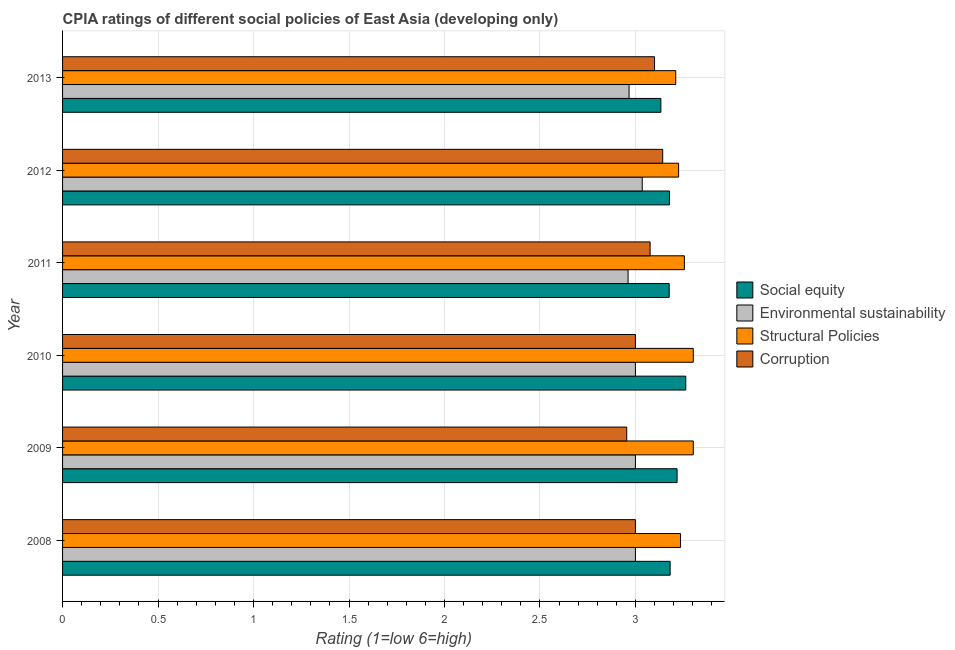How many bars are there on the 3rd tick from the top?
Provide a short and direct response. 4. How many bars are there on the 6th tick from the bottom?
Your response must be concise. 4. What is the label of the 6th group of bars from the top?
Provide a succinct answer. 2008. What is the cpia rating of structural policies in 2011?
Offer a terse response. 3.26. Across all years, what is the maximum cpia rating of corruption?
Your answer should be compact. 3.14. Across all years, what is the minimum cpia rating of social equity?
Your answer should be compact. 3.13. In which year was the cpia rating of structural policies maximum?
Your answer should be very brief. 2009. What is the total cpia rating of structural policies in the graph?
Provide a succinct answer. 19.54. What is the difference between the cpia rating of corruption in 2010 and that in 2011?
Your answer should be very brief. -0.08. What is the difference between the cpia rating of social equity in 2008 and the cpia rating of structural policies in 2012?
Your response must be concise. -0.04. What is the average cpia rating of social equity per year?
Make the answer very short. 3.19. In the year 2008, what is the difference between the cpia rating of corruption and cpia rating of social equity?
Offer a very short reply. -0.18. In how many years, is the cpia rating of structural policies greater than 2.3 ?
Your answer should be very brief. 6. What is the ratio of the cpia rating of structural policies in 2009 to that in 2012?
Give a very brief answer. 1.02. What is the difference between the highest and the lowest cpia rating of structural policies?
Ensure brevity in your answer.  0.09. Is the sum of the cpia rating of social equity in 2011 and 2013 greater than the maximum cpia rating of structural policies across all years?
Your answer should be very brief. Yes. What does the 4th bar from the top in 2009 represents?
Your response must be concise. Social equity. What does the 2nd bar from the bottom in 2009 represents?
Provide a succinct answer. Environmental sustainability. How many bars are there?
Your answer should be compact. 24. What is the difference between two consecutive major ticks on the X-axis?
Offer a terse response. 0.5. Are the values on the major ticks of X-axis written in scientific E-notation?
Provide a succinct answer. No. Does the graph contain any zero values?
Offer a terse response. No. Does the graph contain grids?
Offer a terse response. Yes. How many legend labels are there?
Give a very brief answer. 4. How are the legend labels stacked?
Provide a succinct answer. Vertical. What is the title of the graph?
Make the answer very short. CPIA ratings of different social policies of East Asia (developing only). Does "Tertiary schools" appear as one of the legend labels in the graph?
Offer a terse response. No. What is the label or title of the Y-axis?
Offer a terse response. Year. What is the Rating (1=low 6=high) of Social equity in 2008?
Provide a succinct answer. 3.18. What is the Rating (1=low 6=high) of Environmental sustainability in 2008?
Your answer should be compact. 3. What is the Rating (1=low 6=high) in Structural Policies in 2008?
Offer a very short reply. 3.24. What is the Rating (1=low 6=high) in Social equity in 2009?
Offer a very short reply. 3.22. What is the Rating (1=low 6=high) of Environmental sustainability in 2009?
Keep it short and to the point. 3. What is the Rating (1=low 6=high) in Structural Policies in 2009?
Ensure brevity in your answer.  3.3. What is the Rating (1=low 6=high) of Corruption in 2009?
Offer a terse response. 2.95. What is the Rating (1=low 6=high) of Social equity in 2010?
Your answer should be very brief. 3.26. What is the Rating (1=low 6=high) of Environmental sustainability in 2010?
Offer a very short reply. 3. What is the Rating (1=low 6=high) of Structural Policies in 2010?
Offer a very short reply. 3.3. What is the Rating (1=low 6=high) of Social equity in 2011?
Make the answer very short. 3.18. What is the Rating (1=low 6=high) of Environmental sustainability in 2011?
Your answer should be compact. 2.96. What is the Rating (1=low 6=high) in Structural Policies in 2011?
Provide a short and direct response. 3.26. What is the Rating (1=low 6=high) of Corruption in 2011?
Your answer should be compact. 3.08. What is the Rating (1=low 6=high) of Social equity in 2012?
Ensure brevity in your answer.  3.18. What is the Rating (1=low 6=high) of Environmental sustainability in 2012?
Make the answer very short. 3.04. What is the Rating (1=low 6=high) in Structural Policies in 2012?
Offer a very short reply. 3.23. What is the Rating (1=low 6=high) of Corruption in 2012?
Your answer should be very brief. 3.14. What is the Rating (1=low 6=high) in Social equity in 2013?
Your answer should be very brief. 3.13. What is the Rating (1=low 6=high) of Environmental sustainability in 2013?
Offer a very short reply. 2.97. What is the Rating (1=low 6=high) in Structural Policies in 2013?
Keep it short and to the point. 3.21. What is the Rating (1=low 6=high) in Corruption in 2013?
Your answer should be very brief. 3.1. Across all years, what is the maximum Rating (1=low 6=high) in Social equity?
Ensure brevity in your answer.  3.26. Across all years, what is the maximum Rating (1=low 6=high) in Environmental sustainability?
Give a very brief answer. 3.04. Across all years, what is the maximum Rating (1=low 6=high) in Structural Policies?
Make the answer very short. 3.3. Across all years, what is the maximum Rating (1=low 6=high) of Corruption?
Provide a succinct answer. 3.14. Across all years, what is the minimum Rating (1=low 6=high) of Social equity?
Provide a succinct answer. 3.13. Across all years, what is the minimum Rating (1=low 6=high) of Environmental sustainability?
Your answer should be compact. 2.96. Across all years, what is the minimum Rating (1=low 6=high) of Structural Policies?
Ensure brevity in your answer.  3.21. Across all years, what is the minimum Rating (1=low 6=high) of Corruption?
Provide a short and direct response. 2.95. What is the total Rating (1=low 6=high) in Social equity in the graph?
Keep it short and to the point. 19.15. What is the total Rating (1=low 6=high) in Environmental sustainability in the graph?
Make the answer very short. 17.96. What is the total Rating (1=low 6=high) in Structural Policies in the graph?
Offer a terse response. 19.54. What is the total Rating (1=low 6=high) of Corruption in the graph?
Your response must be concise. 18.27. What is the difference between the Rating (1=low 6=high) in Social equity in 2008 and that in 2009?
Keep it short and to the point. -0.04. What is the difference between the Rating (1=low 6=high) of Environmental sustainability in 2008 and that in 2009?
Your answer should be compact. 0. What is the difference between the Rating (1=low 6=high) in Structural Policies in 2008 and that in 2009?
Offer a very short reply. -0.07. What is the difference between the Rating (1=low 6=high) of Corruption in 2008 and that in 2009?
Your answer should be compact. 0.05. What is the difference between the Rating (1=low 6=high) of Social equity in 2008 and that in 2010?
Offer a terse response. -0.08. What is the difference between the Rating (1=low 6=high) of Structural Policies in 2008 and that in 2010?
Offer a terse response. -0.07. What is the difference between the Rating (1=low 6=high) of Social equity in 2008 and that in 2011?
Ensure brevity in your answer.  0. What is the difference between the Rating (1=low 6=high) of Environmental sustainability in 2008 and that in 2011?
Make the answer very short. 0.04. What is the difference between the Rating (1=low 6=high) in Structural Policies in 2008 and that in 2011?
Provide a succinct answer. -0.02. What is the difference between the Rating (1=low 6=high) in Corruption in 2008 and that in 2011?
Provide a succinct answer. -0.08. What is the difference between the Rating (1=low 6=high) of Social equity in 2008 and that in 2012?
Offer a terse response. 0. What is the difference between the Rating (1=low 6=high) in Environmental sustainability in 2008 and that in 2012?
Your answer should be very brief. -0.04. What is the difference between the Rating (1=low 6=high) in Structural Policies in 2008 and that in 2012?
Offer a very short reply. 0.01. What is the difference between the Rating (1=low 6=high) in Corruption in 2008 and that in 2012?
Offer a terse response. -0.14. What is the difference between the Rating (1=low 6=high) in Social equity in 2008 and that in 2013?
Make the answer very short. 0.05. What is the difference between the Rating (1=low 6=high) of Structural Policies in 2008 and that in 2013?
Ensure brevity in your answer.  0.03. What is the difference between the Rating (1=low 6=high) in Corruption in 2008 and that in 2013?
Provide a succinct answer. -0.1. What is the difference between the Rating (1=low 6=high) in Social equity in 2009 and that in 2010?
Provide a short and direct response. -0.05. What is the difference between the Rating (1=low 6=high) in Environmental sustainability in 2009 and that in 2010?
Make the answer very short. 0. What is the difference between the Rating (1=low 6=high) in Corruption in 2009 and that in 2010?
Provide a succinct answer. -0.05. What is the difference between the Rating (1=low 6=high) of Social equity in 2009 and that in 2011?
Offer a terse response. 0.04. What is the difference between the Rating (1=low 6=high) of Environmental sustainability in 2009 and that in 2011?
Your answer should be compact. 0.04. What is the difference between the Rating (1=low 6=high) of Structural Policies in 2009 and that in 2011?
Offer a very short reply. 0.05. What is the difference between the Rating (1=low 6=high) in Corruption in 2009 and that in 2011?
Make the answer very short. -0.12. What is the difference between the Rating (1=low 6=high) in Social equity in 2009 and that in 2012?
Make the answer very short. 0.04. What is the difference between the Rating (1=low 6=high) of Environmental sustainability in 2009 and that in 2012?
Provide a short and direct response. -0.04. What is the difference between the Rating (1=low 6=high) of Structural Policies in 2009 and that in 2012?
Provide a short and direct response. 0.08. What is the difference between the Rating (1=low 6=high) in Corruption in 2009 and that in 2012?
Provide a short and direct response. -0.19. What is the difference between the Rating (1=low 6=high) of Social equity in 2009 and that in 2013?
Your response must be concise. 0.08. What is the difference between the Rating (1=low 6=high) of Environmental sustainability in 2009 and that in 2013?
Make the answer very short. 0.03. What is the difference between the Rating (1=low 6=high) in Structural Policies in 2009 and that in 2013?
Your answer should be compact. 0.09. What is the difference between the Rating (1=low 6=high) in Corruption in 2009 and that in 2013?
Your answer should be very brief. -0.15. What is the difference between the Rating (1=low 6=high) in Social equity in 2010 and that in 2011?
Offer a terse response. 0.09. What is the difference between the Rating (1=low 6=high) in Environmental sustainability in 2010 and that in 2011?
Offer a terse response. 0.04. What is the difference between the Rating (1=low 6=high) in Structural Policies in 2010 and that in 2011?
Your response must be concise. 0.05. What is the difference between the Rating (1=low 6=high) of Corruption in 2010 and that in 2011?
Your answer should be very brief. -0.08. What is the difference between the Rating (1=low 6=high) of Social equity in 2010 and that in 2012?
Keep it short and to the point. 0.09. What is the difference between the Rating (1=low 6=high) in Environmental sustainability in 2010 and that in 2012?
Offer a very short reply. -0.04. What is the difference between the Rating (1=low 6=high) of Structural Policies in 2010 and that in 2012?
Offer a terse response. 0.08. What is the difference between the Rating (1=low 6=high) of Corruption in 2010 and that in 2012?
Give a very brief answer. -0.14. What is the difference between the Rating (1=low 6=high) of Social equity in 2010 and that in 2013?
Keep it short and to the point. 0.13. What is the difference between the Rating (1=low 6=high) of Environmental sustainability in 2010 and that in 2013?
Keep it short and to the point. 0.03. What is the difference between the Rating (1=low 6=high) of Structural Policies in 2010 and that in 2013?
Keep it short and to the point. 0.09. What is the difference between the Rating (1=low 6=high) of Corruption in 2010 and that in 2013?
Your answer should be very brief. -0.1. What is the difference between the Rating (1=low 6=high) in Social equity in 2011 and that in 2012?
Offer a terse response. -0. What is the difference between the Rating (1=low 6=high) of Environmental sustainability in 2011 and that in 2012?
Make the answer very short. -0.07. What is the difference between the Rating (1=low 6=high) of Structural Policies in 2011 and that in 2012?
Offer a very short reply. 0.03. What is the difference between the Rating (1=low 6=high) in Corruption in 2011 and that in 2012?
Offer a very short reply. -0.07. What is the difference between the Rating (1=low 6=high) of Social equity in 2011 and that in 2013?
Your answer should be very brief. 0.04. What is the difference between the Rating (1=low 6=high) of Environmental sustainability in 2011 and that in 2013?
Your answer should be very brief. -0.01. What is the difference between the Rating (1=low 6=high) in Structural Policies in 2011 and that in 2013?
Offer a terse response. 0.05. What is the difference between the Rating (1=low 6=high) in Corruption in 2011 and that in 2013?
Ensure brevity in your answer.  -0.02. What is the difference between the Rating (1=low 6=high) of Social equity in 2012 and that in 2013?
Give a very brief answer. 0.05. What is the difference between the Rating (1=low 6=high) in Environmental sustainability in 2012 and that in 2013?
Your answer should be very brief. 0.07. What is the difference between the Rating (1=low 6=high) in Structural Policies in 2012 and that in 2013?
Provide a succinct answer. 0.02. What is the difference between the Rating (1=low 6=high) of Corruption in 2012 and that in 2013?
Your answer should be compact. 0.04. What is the difference between the Rating (1=low 6=high) of Social equity in 2008 and the Rating (1=low 6=high) of Environmental sustainability in 2009?
Offer a very short reply. 0.18. What is the difference between the Rating (1=low 6=high) of Social equity in 2008 and the Rating (1=low 6=high) of Structural Policies in 2009?
Make the answer very short. -0.12. What is the difference between the Rating (1=low 6=high) of Social equity in 2008 and the Rating (1=low 6=high) of Corruption in 2009?
Your answer should be compact. 0.23. What is the difference between the Rating (1=low 6=high) of Environmental sustainability in 2008 and the Rating (1=low 6=high) of Structural Policies in 2009?
Offer a very short reply. -0.3. What is the difference between the Rating (1=low 6=high) in Environmental sustainability in 2008 and the Rating (1=low 6=high) in Corruption in 2009?
Keep it short and to the point. 0.05. What is the difference between the Rating (1=low 6=high) of Structural Policies in 2008 and the Rating (1=low 6=high) of Corruption in 2009?
Your response must be concise. 0.28. What is the difference between the Rating (1=low 6=high) in Social equity in 2008 and the Rating (1=low 6=high) in Environmental sustainability in 2010?
Ensure brevity in your answer.  0.18. What is the difference between the Rating (1=low 6=high) in Social equity in 2008 and the Rating (1=low 6=high) in Structural Policies in 2010?
Provide a succinct answer. -0.12. What is the difference between the Rating (1=low 6=high) of Social equity in 2008 and the Rating (1=low 6=high) of Corruption in 2010?
Give a very brief answer. 0.18. What is the difference between the Rating (1=low 6=high) in Environmental sustainability in 2008 and the Rating (1=low 6=high) in Structural Policies in 2010?
Your answer should be compact. -0.3. What is the difference between the Rating (1=low 6=high) in Environmental sustainability in 2008 and the Rating (1=low 6=high) in Corruption in 2010?
Ensure brevity in your answer.  0. What is the difference between the Rating (1=low 6=high) of Structural Policies in 2008 and the Rating (1=low 6=high) of Corruption in 2010?
Offer a very short reply. 0.24. What is the difference between the Rating (1=low 6=high) of Social equity in 2008 and the Rating (1=low 6=high) of Environmental sustainability in 2011?
Keep it short and to the point. 0.22. What is the difference between the Rating (1=low 6=high) in Social equity in 2008 and the Rating (1=low 6=high) in Structural Policies in 2011?
Your answer should be very brief. -0.07. What is the difference between the Rating (1=low 6=high) in Social equity in 2008 and the Rating (1=low 6=high) in Corruption in 2011?
Offer a terse response. 0.1. What is the difference between the Rating (1=low 6=high) of Environmental sustainability in 2008 and the Rating (1=low 6=high) of Structural Policies in 2011?
Your answer should be compact. -0.26. What is the difference between the Rating (1=low 6=high) of Environmental sustainability in 2008 and the Rating (1=low 6=high) of Corruption in 2011?
Make the answer very short. -0.08. What is the difference between the Rating (1=low 6=high) of Structural Policies in 2008 and the Rating (1=low 6=high) of Corruption in 2011?
Offer a very short reply. 0.16. What is the difference between the Rating (1=low 6=high) in Social equity in 2008 and the Rating (1=low 6=high) in Environmental sustainability in 2012?
Provide a short and direct response. 0.15. What is the difference between the Rating (1=low 6=high) in Social equity in 2008 and the Rating (1=low 6=high) in Structural Policies in 2012?
Provide a succinct answer. -0.04. What is the difference between the Rating (1=low 6=high) in Social equity in 2008 and the Rating (1=low 6=high) in Corruption in 2012?
Keep it short and to the point. 0.04. What is the difference between the Rating (1=low 6=high) of Environmental sustainability in 2008 and the Rating (1=low 6=high) of Structural Policies in 2012?
Your answer should be very brief. -0.23. What is the difference between the Rating (1=low 6=high) in Environmental sustainability in 2008 and the Rating (1=low 6=high) in Corruption in 2012?
Give a very brief answer. -0.14. What is the difference between the Rating (1=low 6=high) in Structural Policies in 2008 and the Rating (1=low 6=high) in Corruption in 2012?
Ensure brevity in your answer.  0.09. What is the difference between the Rating (1=low 6=high) of Social equity in 2008 and the Rating (1=low 6=high) of Environmental sustainability in 2013?
Give a very brief answer. 0.22. What is the difference between the Rating (1=low 6=high) in Social equity in 2008 and the Rating (1=low 6=high) in Structural Policies in 2013?
Make the answer very short. -0.03. What is the difference between the Rating (1=low 6=high) of Social equity in 2008 and the Rating (1=low 6=high) of Corruption in 2013?
Offer a very short reply. 0.08. What is the difference between the Rating (1=low 6=high) of Environmental sustainability in 2008 and the Rating (1=low 6=high) of Structural Policies in 2013?
Provide a succinct answer. -0.21. What is the difference between the Rating (1=low 6=high) of Structural Policies in 2008 and the Rating (1=low 6=high) of Corruption in 2013?
Your answer should be compact. 0.14. What is the difference between the Rating (1=low 6=high) in Social equity in 2009 and the Rating (1=low 6=high) in Environmental sustainability in 2010?
Offer a terse response. 0.22. What is the difference between the Rating (1=low 6=high) in Social equity in 2009 and the Rating (1=low 6=high) in Structural Policies in 2010?
Give a very brief answer. -0.08. What is the difference between the Rating (1=low 6=high) of Social equity in 2009 and the Rating (1=low 6=high) of Corruption in 2010?
Your answer should be very brief. 0.22. What is the difference between the Rating (1=low 6=high) in Environmental sustainability in 2009 and the Rating (1=low 6=high) in Structural Policies in 2010?
Provide a succinct answer. -0.3. What is the difference between the Rating (1=low 6=high) in Environmental sustainability in 2009 and the Rating (1=low 6=high) in Corruption in 2010?
Provide a succinct answer. 0. What is the difference between the Rating (1=low 6=high) of Structural Policies in 2009 and the Rating (1=low 6=high) of Corruption in 2010?
Provide a short and direct response. 0.3. What is the difference between the Rating (1=low 6=high) in Social equity in 2009 and the Rating (1=low 6=high) in Environmental sustainability in 2011?
Offer a very short reply. 0.26. What is the difference between the Rating (1=low 6=high) in Social equity in 2009 and the Rating (1=low 6=high) in Structural Policies in 2011?
Keep it short and to the point. -0.04. What is the difference between the Rating (1=low 6=high) in Social equity in 2009 and the Rating (1=low 6=high) in Corruption in 2011?
Ensure brevity in your answer.  0.14. What is the difference between the Rating (1=low 6=high) of Environmental sustainability in 2009 and the Rating (1=low 6=high) of Structural Policies in 2011?
Offer a terse response. -0.26. What is the difference between the Rating (1=low 6=high) of Environmental sustainability in 2009 and the Rating (1=low 6=high) of Corruption in 2011?
Keep it short and to the point. -0.08. What is the difference between the Rating (1=low 6=high) of Structural Policies in 2009 and the Rating (1=low 6=high) of Corruption in 2011?
Give a very brief answer. 0.23. What is the difference between the Rating (1=low 6=high) of Social equity in 2009 and the Rating (1=low 6=high) of Environmental sustainability in 2012?
Your answer should be compact. 0.18. What is the difference between the Rating (1=low 6=high) in Social equity in 2009 and the Rating (1=low 6=high) in Structural Policies in 2012?
Offer a terse response. -0.01. What is the difference between the Rating (1=low 6=high) in Social equity in 2009 and the Rating (1=low 6=high) in Corruption in 2012?
Offer a very short reply. 0.08. What is the difference between the Rating (1=low 6=high) in Environmental sustainability in 2009 and the Rating (1=low 6=high) in Structural Policies in 2012?
Provide a short and direct response. -0.23. What is the difference between the Rating (1=low 6=high) in Environmental sustainability in 2009 and the Rating (1=low 6=high) in Corruption in 2012?
Your response must be concise. -0.14. What is the difference between the Rating (1=low 6=high) of Structural Policies in 2009 and the Rating (1=low 6=high) of Corruption in 2012?
Ensure brevity in your answer.  0.16. What is the difference between the Rating (1=low 6=high) in Social equity in 2009 and the Rating (1=low 6=high) in Environmental sustainability in 2013?
Provide a succinct answer. 0.25. What is the difference between the Rating (1=low 6=high) of Social equity in 2009 and the Rating (1=low 6=high) of Structural Policies in 2013?
Ensure brevity in your answer.  0.01. What is the difference between the Rating (1=low 6=high) in Social equity in 2009 and the Rating (1=low 6=high) in Corruption in 2013?
Your response must be concise. 0.12. What is the difference between the Rating (1=low 6=high) in Environmental sustainability in 2009 and the Rating (1=low 6=high) in Structural Policies in 2013?
Make the answer very short. -0.21. What is the difference between the Rating (1=low 6=high) in Structural Policies in 2009 and the Rating (1=low 6=high) in Corruption in 2013?
Provide a short and direct response. 0.2. What is the difference between the Rating (1=low 6=high) in Social equity in 2010 and the Rating (1=low 6=high) in Environmental sustainability in 2011?
Offer a terse response. 0.3. What is the difference between the Rating (1=low 6=high) in Social equity in 2010 and the Rating (1=low 6=high) in Structural Policies in 2011?
Keep it short and to the point. 0.01. What is the difference between the Rating (1=low 6=high) of Social equity in 2010 and the Rating (1=low 6=high) of Corruption in 2011?
Make the answer very short. 0.19. What is the difference between the Rating (1=low 6=high) in Environmental sustainability in 2010 and the Rating (1=low 6=high) in Structural Policies in 2011?
Keep it short and to the point. -0.26. What is the difference between the Rating (1=low 6=high) of Environmental sustainability in 2010 and the Rating (1=low 6=high) of Corruption in 2011?
Offer a very short reply. -0.08. What is the difference between the Rating (1=low 6=high) in Structural Policies in 2010 and the Rating (1=low 6=high) in Corruption in 2011?
Give a very brief answer. 0.23. What is the difference between the Rating (1=low 6=high) of Social equity in 2010 and the Rating (1=low 6=high) of Environmental sustainability in 2012?
Ensure brevity in your answer.  0.23. What is the difference between the Rating (1=low 6=high) in Social equity in 2010 and the Rating (1=low 6=high) in Structural Policies in 2012?
Your answer should be very brief. 0.04. What is the difference between the Rating (1=low 6=high) of Social equity in 2010 and the Rating (1=low 6=high) of Corruption in 2012?
Your answer should be compact. 0.12. What is the difference between the Rating (1=low 6=high) of Environmental sustainability in 2010 and the Rating (1=low 6=high) of Structural Policies in 2012?
Give a very brief answer. -0.23. What is the difference between the Rating (1=low 6=high) in Environmental sustainability in 2010 and the Rating (1=low 6=high) in Corruption in 2012?
Offer a terse response. -0.14. What is the difference between the Rating (1=low 6=high) in Structural Policies in 2010 and the Rating (1=low 6=high) in Corruption in 2012?
Give a very brief answer. 0.16. What is the difference between the Rating (1=low 6=high) of Social equity in 2010 and the Rating (1=low 6=high) of Environmental sustainability in 2013?
Your response must be concise. 0.3. What is the difference between the Rating (1=low 6=high) of Social equity in 2010 and the Rating (1=low 6=high) of Structural Policies in 2013?
Offer a terse response. 0.05. What is the difference between the Rating (1=low 6=high) of Social equity in 2010 and the Rating (1=low 6=high) of Corruption in 2013?
Offer a very short reply. 0.16. What is the difference between the Rating (1=low 6=high) of Environmental sustainability in 2010 and the Rating (1=low 6=high) of Structural Policies in 2013?
Provide a succinct answer. -0.21. What is the difference between the Rating (1=low 6=high) in Structural Policies in 2010 and the Rating (1=low 6=high) in Corruption in 2013?
Offer a terse response. 0.2. What is the difference between the Rating (1=low 6=high) of Social equity in 2011 and the Rating (1=low 6=high) of Environmental sustainability in 2012?
Offer a very short reply. 0.14. What is the difference between the Rating (1=low 6=high) of Social equity in 2011 and the Rating (1=low 6=high) of Structural Policies in 2012?
Your response must be concise. -0.05. What is the difference between the Rating (1=low 6=high) of Social equity in 2011 and the Rating (1=low 6=high) of Corruption in 2012?
Give a very brief answer. 0.03. What is the difference between the Rating (1=low 6=high) in Environmental sustainability in 2011 and the Rating (1=low 6=high) in Structural Policies in 2012?
Your answer should be very brief. -0.26. What is the difference between the Rating (1=low 6=high) of Environmental sustainability in 2011 and the Rating (1=low 6=high) of Corruption in 2012?
Your answer should be compact. -0.18. What is the difference between the Rating (1=low 6=high) of Structural Policies in 2011 and the Rating (1=low 6=high) of Corruption in 2012?
Offer a terse response. 0.11. What is the difference between the Rating (1=low 6=high) in Social equity in 2011 and the Rating (1=low 6=high) in Environmental sustainability in 2013?
Keep it short and to the point. 0.21. What is the difference between the Rating (1=low 6=high) of Social equity in 2011 and the Rating (1=low 6=high) of Structural Policies in 2013?
Provide a succinct answer. -0.03. What is the difference between the Rating (1=low 6=high) in Social equity in 2011 and the Rating (1=low 6=high) in Corruption in 2013?
Your response must be concise. 0.08. What is the difference between the Rating (1=low 6=high) of Environmental sustainability in 2011 and the Rating (1=low 6=high) of Structural Policies in 2013?
Ensure brevity in your answer.  -0.25. What is the difference between the Rating (1=low 6=high) of Environmental sustainability in 2011 and the Rating (1=low 6=high) of Corruption in 2013?
Keep it short and to the point. -0.14. What is the difference between the Rating (1=low 6=high) of Structural Policies in 2011 and the Rating (1=low 6=high) of Corruption in 2013?
Your answer should be compact. 0.16. What is the difference between the Rating (1=low 6=high) in Social equity in 2012 and the Rating (1=low 6=high) in Environmental sustainability in 2013?
Your response must be concise. 0.21. What is the difference between the Rating (1=low 6=high) in Social equity in 2012 and the Rating (1=low 6=high) in Structural Policies in 2013?
Offer a very short reply. -0.03. What is the difference between the Rating (1=low 6=high) in Social equity in 2012 and the Rating (1=low 6=high) in Corruption in 2013?
Your answer should be compact. 0.08. What is the difference between the Rating (1=low 6=high) in Environmental sustainability in 2012 and the Rating (1=low 6=high) in Structural Policies in 2013?
Your answer should be compact. -0.18. What is the difference between the Rating (1=low 6=high) of Environmental sustainability in 2012 and the Rating (1=low 6=high) of Corruption in 2013?
Offer a terse response. -0.06. What is the difference between the Rating (1=low 6=high) of Structural Policies in 2012 and the Rating (1=low 6=high) of Corruption in 2013?
Ensure brevity in your answer.  0.13. What is the average Rating (1=low 6=high) in Social equity per year?
Ensure brevity in your answer.  3.19. What is the average Rating (1=low 6=high) in Environmental sustainability per year?
Make the answer very short. 2.99. What is the average Rating (1=low 6=high) in Structural Policies per year?
Give a very brief answer. 3.26. What is the average Rating (1=low 6=high) in Corruption per year?
Your answer should be compact. 3.05. In the year 2008, what is the difference between the Rating (1=low 6=high) of Social equity and Rating (1=low 6=high) of Environmental sustainability?
Ensure brevity in your answer.  0.18. In the year 2008, what is the difference between the Rating (1=low 6=high) in Social equity and Rating (1=low 6=high) in Structural Policies?
Provide a short and direct response. -0.05. In the year 2008, what is the difference between the Rating (1=low 6=high) of Social equity and Rating (1=low 6=high) of Corruption?
Ensure brevity in your answer.  0.18. In the year 2008, what is the difference between the Rating (1=low 6=high) in Environmental sustainability and Rating (1=low 6=high) in Structural Policies?
Give a very brief answer. -0.24. In the year 2008, what is the difference between the Rating (1=low 6=high) in Structural Policies and Rating (1=low 6=high) in Corruption?
Your answer should be compact. 0.24. In the year 2009, what is the difference between the Rating (1=low 6=high) in Social equity and Rating (1=low 6=high) in Environmental sustainability?
Give a very brief answer. 0.22. In the year 2009, what is the difference between the Rating (1=low 6=high) in Social equity and Rating (1=low 6=high) in Structural Policies?
Offer a very short reply. -0.08. In the year 2009, what is the difference between the Rating (1=low 6=high) of Social equity and Rating (1=low 6=high) of Corruption?
Give a very brief answer. 0.26. In the year 2009, what is the difference between the Rating (1=low 6=high) of Environmental sustainability and Rating (1=low 6=high) of Structural Policies?
Offer a terse response. -0.3. In the year 2009, what is the difference between the Rating (1=low 6=high) of Environmental sustainability and Rating (1=low 6=high) of Corruption?
Keep it short and to the point. 0.05. In the year 2009, what is the difference between the Rating (1=low 6=high) of Structural Policies and Rating (1=low 6=high) of Corruption?
Give a very brief answer. 0.35. In the year 2010, what is the difference between the Rating (1=low 6=high) in Social equity and Rating (1=low 6=high) in Environmental sustainability?
Your answer should be very brief. 0.26. In the year 2010, what is the difference between the Rating (1=low 6=high) of Social equity and Rating (1=low 6=high) of Structural Policies?
Provide a succinct answer. -0.04. In the year 2010, what is the difference between the Rating (1=low 6=high) in Social equity and Rating (1=low 6=high) in Corruption?
Provide a succinct answer. 0.26. In the year 2010, what is the difference between the Rating (1=low 6=high) in Environmental sustainability and Rating (1=low 6=high) in Structural Policies?
Your answer should be compact. -0.3. In the year 2010, what is the difference between the Rating (1=low 6=high) in Environmental sustainability and Rating (1=low 6=high) in Corruption?
Make the answer very short. 0. In the year 2010, what is the difference between the Rating (1=low 6=high) of Structural Policies and Rating (1=low 6=high) of Corruption?
Keep it short and to the point. 0.3. In the year 2011, what is the difference between the Rating (1=low 6=high) of Social equity and Rating (1=low 6=high) of Environmental sustainability?
Provide a short and direct response. 0.22. In the year 2011, what is the difference between the Rating (1=low 6=high) of Social equity and Rating (1=low 6=high) of Structural Policies?
Offer a terse response. -0.08. In the year 2011, what is the difference between the Rating (1=low 6=high) in Environmental sustainability and Rating (1=low 6=high) in Structural Policies?
Give a very brief answer. -0.29. In the year 2011, what is the difference between the Rating (1=low 6=high) in Environmental sustainability and Rating (1=low 6=high) in Corruption?
Offer a very short reply. -0.12. In the year 2011, what is the difference between the Rating (1=low 6=high) in Structural Policies and Rating (1=low 6=high) in Corruption?
Offer a very short reply. 0.18. In the year 2012, what is the difference between the Rating (1=low 6=high) in Social equity and Rating (1=low 6=high) in Environmental sustainability?
Your answer should be compact. 0.14. In the year 2012, what is the difference between the Rating (1=low 6=high) in Social equity and Rating (1=low 6=high) in Structural Policies?
Offer a very short reply. -0.05. In the year 2012, what is the difference between the Rating (1=low 6=high) in Social equity and Rating (1=low 6=high) in Corruption?
Ensure brevity in your answer.  0.04. In the year 2012, what is the difference between the Rating (1=low 6=high) of Environmental sustainability and Rating (1=low 6=high) of Structural Policies?
Make the answer very short. -0.19. In the year 2012, what is the difference between the Rating (1=low 6=high) in Environmental sustainability and Rating (1=low 6=high) in Corruption?
Offer a very short reply. -0.11. In the year 2012, what is the difference between the Rating (1=low 6=high) in Structural Policies and Rating (1=low 6=high) in Corruption?
Keep it short and to the point. 0.08. In the year 2013, what is the difference between the Rating (1=low 6=high) in Social equity and Rating (1=low 6=high) in Environmental sustainability?
Provide a short and direct response. 0.17. In the year 2013, what is the difference between the Rating (1=low 6=high) in Social equity and Rating (1=low 6=high) in Structural Policies?
Keep it short and to the point. -0.08. In the year 2013, what is the difference between the Rating (1=low 6=high) in Environmental sustainability and Rating (1=low 6=high) in Structural Policies?
Offer a very short reply. -0.24. In the year 2013, what is the difference between the Rating (1=low 6=high) of Environmental sustainability and Rating (1=low 6=high) of Corruption?
Your answer should be compact. -0.13. In the year 2013, what is the difference between the Rating (1=low 6=high) of Structural Policies and Rating (1=low 6=high) of Corruption?
Your answer should be compact. 0.11. What is the ratio of the Rating (1=low 6=high) in Social equity in 2008 to that in 2009?
Ensure brevity in your answer.  0.99. What is the ratio of the Rating (1=low 6=high) in Environmental sustainability in 2008 to that in 2009?
Ensure brevity in your answer.  1. What is the ratio of the Rating (1=low 6=high) of Structural Policies in 2008 to that in 2009?
Make the answer very short. 0.98. What is the ratio of the Rating (1=low 6=high) in Corruption in 2008 to that in 2009?
Ensure brevity in your answer.  1.02. What is the ratio of the Rating (1=low 6=high) in Social equity in 2008 to that in 2010?
Your answer should be very brief. 0.97. What is the ratio of the Rating (1=low 6=high) in Environmental sustainability in 2008 to that in 2010?
Offer a terse response. 1. What is the ratio of the Rating (1=low 6=high) of Structural Policies in 2008 to that in 2010?
Your answer should be compact. 0.98. What is the ratio of the Rating (1=low 6=high) in Structural Policies in 2008 to that in 2011?
Offer a very short reply. 0.99. What is the ratio of the Rating (1=low 6=high) in Environmental sustainability in 2008 to that in 2012?
Provide a succinct answer. 0.99. What is the ratio of the Rating (1=low 6=high) in Corruption in 2008 to that in 2012?
Your response must be concise. 0.95. What is the ratio of the Rating (1=low 6=high) of Social equity in 2008 to that in 2013?
Offer a very short reply. 1.02. What is the ratio of the Rating (1=low 6=high) of Environmental sustainability in 2008 to that in 2013?
Offer a very short reply. 1.01. What is the ratio of the Rating (1=low 6=high) of Structural Policies in 2008 to that in 2013?
Ensure brevity in your answer.  1.01. What is the ratio of the Rating (1=low 6=high) in Social equity in 2009 to that in 2010?
Your response must be concise. 0.99. What is the ratio of the Rating (1=low 6=high) of Environmental sustainability in 2009 to that in 2010?
Make the answer very short. 1. What is the ratio of the Rating (1=low 6=high) of Structural Policies in 2009 to that in 2010?
Provide a succinct answer. 1. What is the ratio of the Rating (1=low 6=high) in Environmental sustainability in 2009 to that in 2011?
Your answer should be compact. 1.01. What is the ratio of the Rating (1=low 6=high) of Structural Policies in 2009 to that in 2011?
Your response must be concise. 1.01. What is the ratio of the Rating (1=low 6=high) of Corruption in 2009 to that in 2011?
Give a very brief answer. 0.96. What is the ratio of the Rating (1=low 6=high) of Social equity in 2009 to that in 2012?
Provide a short and direct response. 1.01. What is the ratio of the Rating (1=low 6=high) in Structural Policies in 2009 to that in 2012?
Offer a very short reply. 1.02. What is the ratio of the Rating (1=low 6=high) in Corruption in 2009 to that in 2012?
Provide a succinct answer. 0.94. What is the ratio of the Rating (1=low 6=high) in Social equity in 2009 to that in 2013?
Keep it short and to the point. 1.03. What is the ratio of the Rating (1=low 6=high) of Environmental sustainability in 2009 to that in 2013?
Offer a very short reply. 1.01. What is the ratio of the Rating (1=low 6=high) of Structural Policies in 2009 to that in 2013?
Offer a terse response. 1.03. What is the ratio of the Rating (1=low 6=high) of Corruption in 2009 to that in 2013?
Offer a very short reply. 0.95. What is the ratio of the Rating (1=low 6=high) of Social equity in 2010 to that in 2011?
Make the answer very short. 1.03. What is the ratio of the Rating (1=low 6=high) in Environmental sustainability in 2010 to that in 2011?
Your response must be concise. 1.01. What is the ratio of the Rating (1=low 6=high) of Structural Policies in 2010 to that in 2011?
Make the answer very short. 1.01. What is the ratio of the Rating (1=low 6=high) in Social equity in 2010 to that in 2012?
Provide a short and direct response. 1.03. What is the ratio of the Rating (1=low 6=high) in Structural Policies in 2010 to that in 2012?
Provide a succinct answer. 1.02. What is the ratio of the Rating (1=low 6=high) of Corruption in 2010 to that in 2012?
Ensure brevity in your answer.  0.95. What is the ratio of the Rating (1=low 6=high) of Social equity in 2010 to that in 2013?
Your answer should be very brief. 1.04. What is the ratio of the Rating (1=low 6=high) of Environmental sustainability in 2010 to that in 2013?
Make the answer very short. 1.01. What is the ratio of the Rating (1=low 6=high) of Structural Policies in 2010 to that in 2013?
Provide a succinct answer. 1.03. What is the ratio of the Rating (1=low 6=high) of Corruption in 2010 to that in 2013?
Your response must be concise. 0.97. What is the ratio of the Rating (1=low 6=high) of Environmental sustainability in 2011 to that in 2012?
Provide a succinct answer. 0.98. What is the ratio of the Rating (1=low 6=high) of Structural Policies in 2011 to that in 2012?
Offer a very short reply. 1.01. What is the ratio of the Rating (1=low 6=high) in Corruption in 2011 to that in 2012?
Your response must be concise. 0.98. What is the ratio of the Rating (1=low 6=high) in Social equity in 2011 to that in 2013?
Offer a terse response. 1.01. What is the ratio of the Rating (1=low 6=high) of Structural Policies in 2011 to that in 2013?
Keep it short and to the point. 1.01. What is the ratio of the Rating (1=low 6=high) in Corruption in 2011 to that in 2013?
Keep it short and to the point. 0.99. What is the ratio of the Rating (1=low 6=high) in Social equity in 2012 to that in 2013?
Your answer should be compact. 1.01. What is the ratio of the Rating (1=low 6=high) of Environmental sustainability in 2012 to that in 2013?
Provide a short and direct response. 1.02. What is the ratio of the Rating (1=low 6=high) of Structural Policies in 2012 to that in 2013?
Provide a succinct answer. 1. What is the ratio of the Rating (1=low 6=high) of Corruption in 2012 to that in 2013?
Your response must be concise. 1.01. What is the difference between the highest and the second highest Rating (1=low 6=high) of Social equity?
Ensure brevity in your answer.  0.05. What is the difference between the highest and the second highest Rating (1=low 6=high) of Environmental sustainability?
Provide a short and direct response. 0.04. What is the difference between the highest and the second highest Rating (1=low 6=high) in Corruption?
Keep it short and to the point. 0.04. What is the difference between the highest and the lowest Rating (1=low 6=high) of Social equity?
Provide a succinct answer. 0.13. What is the difference between the highest and the lowest Rating (1=low 6=high) in Environmental sustainability?
Ensure brevity in your answer.  0.07. What is the difference between the highest and the lowest Rating (1=low 6=high) of Structural Policies?
Offer a very short reply. 0.09. What is the difference between the highest and the lowest Rating (1=low 6=high) in Corruption?
Provide a short and direct response. 0.19. 